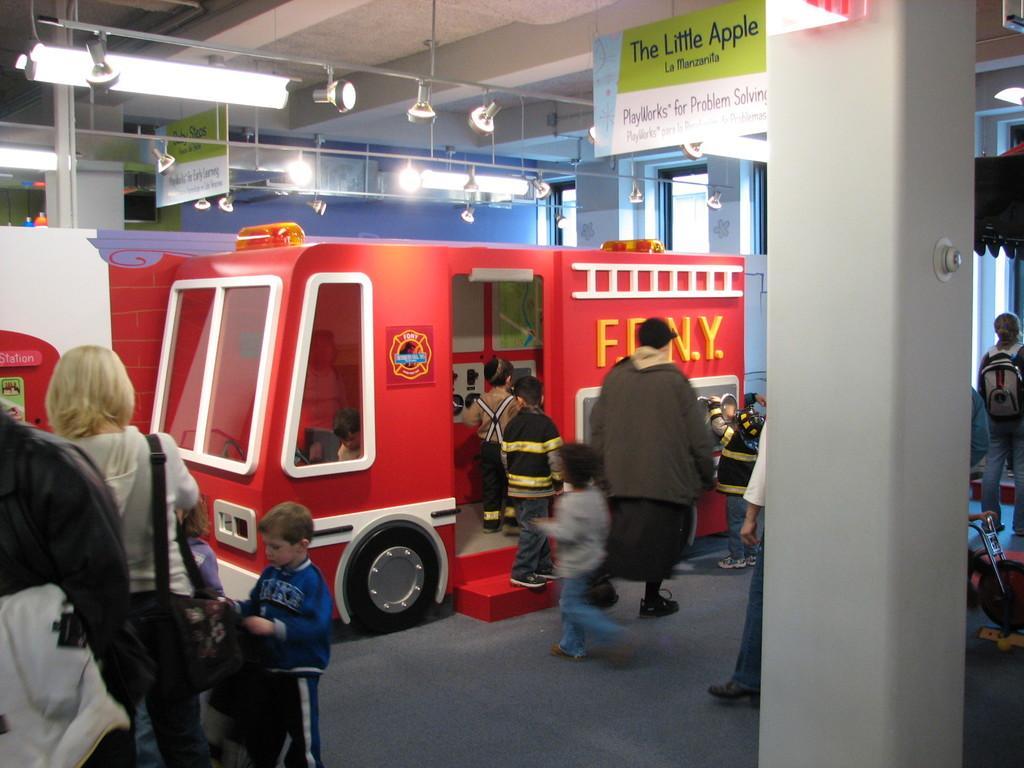Please provide a concise description of this image. In this image we can see many people. Some are wearing bags. Also there is a pillar. And there is a toy vehicle. Also there are boards with text. On the ceiling there are lights. Also there are glass walls. 